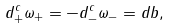Convert formula to latex. <formula><loc_0><loc_0><loc_500><loc_500>d ^ { c } _ { + } \omega _ { + } = - d ^ { c } _ { - } \omega _ { - } = d b ,</formula> 